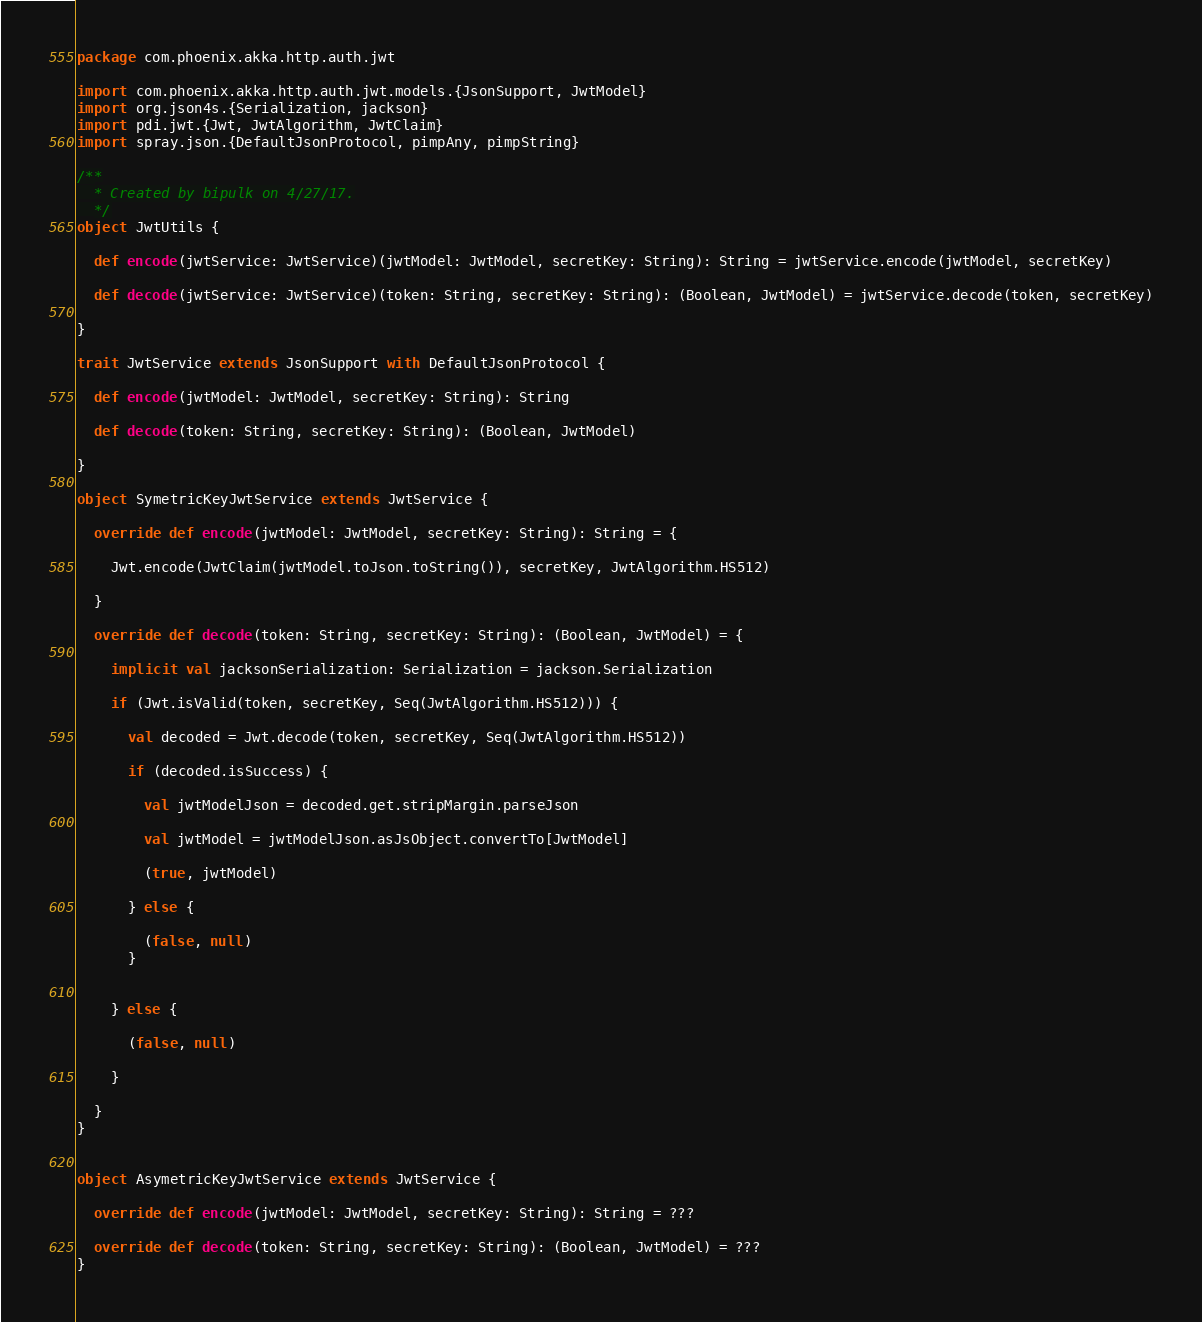<code> <loc_0><loc_0><loc_500><loc_500><_Scala_>package com.phoenix.akka.http.auth.jwt

import com.phoenix.akka.http.auth.jwt.models.{JsonSupport, JwtModel}
import org.json4s.{Serialization, jackson}
import pdi.jwt.{Jwt, JwtAlgorithm, JwtClaim}
import spray.json.{DefaultJsonProtocol, pimpAny, pimpString}

/**
  * Created by bipulk on 4/27/17.
  */
object JwtUtils {

  def encode(jwtService: JwtService)(jwtModel: JwtModel, secretKey: String): String = jwtService.encode(jwtModel, secretKey)

  def decode(jwtService: JwtService)(token: String, secretKey: String): (Boolean, JwtModel) = jwtService.decode(token, secretKey)

}

trait JwtService extends JsonSupport with DefaultJsonProtocol {

  def encode(jwtModel: JwtModel, secretKey: String): String

  def decode(token: String, secretKey: String): (Boolean, JwtModel)

}

object SymetricKeyJwtService extends JwtService {

  override def encode(jwtModel: JwtModel, secretKey: String): String = {

    Jwt.encode(JwtClaim(jwtModel.toJson.toString()), secretKey, JwtAlgorithm.HS512)

  }

  override def decode(token: String, secretKey: String): (Boolean, JwtModel) = {

    implicit val jacksonSerialization: Serialization = jackson.Serialization

    if (Jwt.isValid(token, secretKey, Seq(JwtAlgorithm.HS512))) {

      val decoded = Jwt.decode(token, secretKey, Seq(JwtAlgorithm.HS512))

      if (decoded.isSuccess) {

        val jwtModelJson = decoded.get.stripMargin.parseJson

        val jwtModel = jwtModelJson.asJsObject.convertTo[JwtModel]

        (true, jwtModel)

      } else {

        (false, null)
      }


    } else {

      (false, null)

    }

  }
}


object AsymetricKeyJwtService extends JwtService {

  override def encode(jwtModel: JwtModel, secretKey: String): String = ???

  override def decode(token: String, secretKey: String): (Boolean, JwtModel) = ???
}</code> 